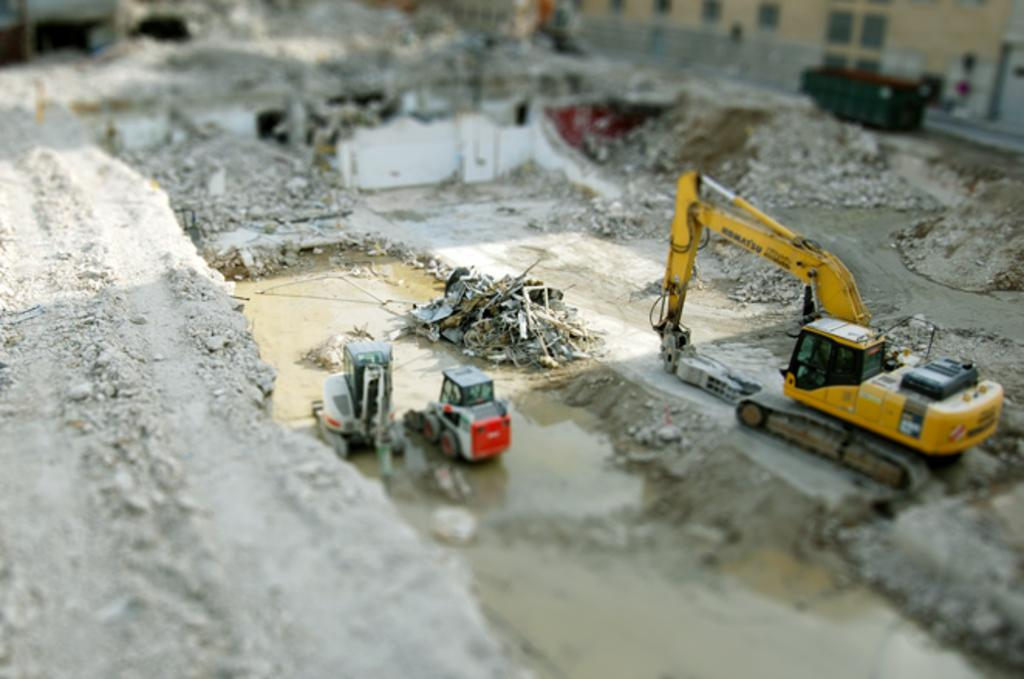What type of vehicles can be seen in the image? There are earth moving vehicles in the image. What else can be seen in the image besides the vehicles? There are houses in the image. What color is the line on the roof of the house in the image? There is no line or roof mentioned in the provided facts, and therefore no such detail can be observed in the image. 